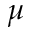<formula> <loc_0><loc_0><loc_500><loc_500>\mu</formula> 